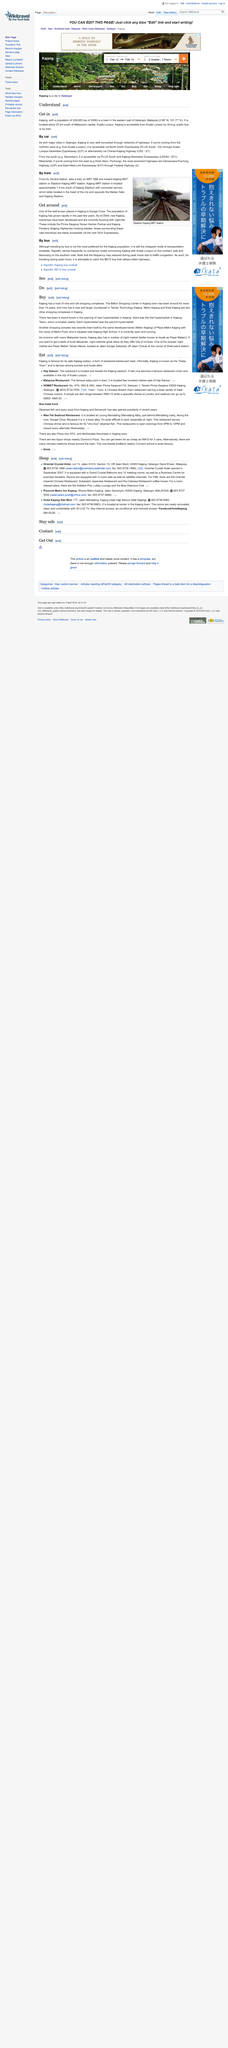Indicate a few pertinent items in this graphic. The above picture represents the Stadium Kajang MRT station. The Kuala Lumpur-Seremban Expressway has been designated as E37. In recent times, hypermarkets and shopping complexes such as Giant, Tesco, and Metro Point have made their debut in Kajang, catering to the needs of shoppers in the area. Kuala Lumpur is not located to the south of Kajang, but rather to the north. Yes, Shah Alam is located to the west of Kajang. 